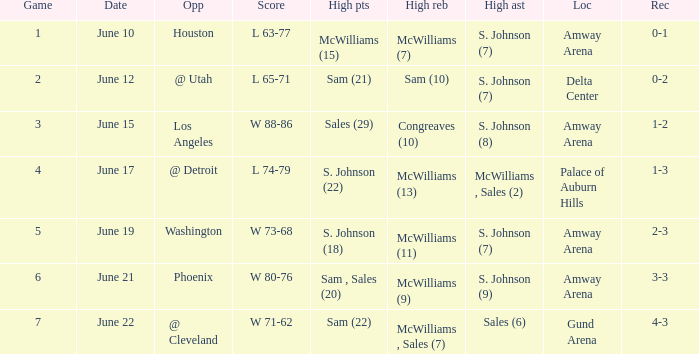Name the opponent for june 12 @ Utah. 